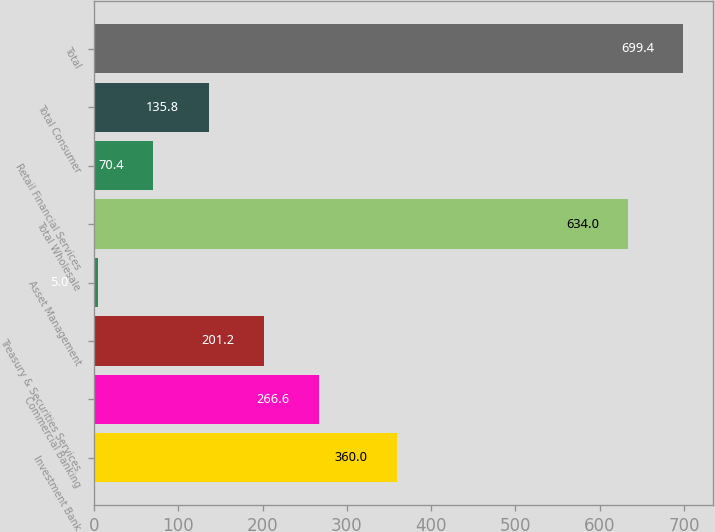Convert chart. <chart><loc_0><loc_0><loc_500><loc_500><bar_chart><fcel>Investment Bank<fcel>Commercial Banking<fcel>Treasury & Securities Services<fcel>Asset Management<fcel>Total Wholesale<fcel>Retail Financial Services<fcel>Total Consumer<fcel>Total<nl><fcel>360<fcel>266.6<fcel>201.2<fcel>5<fcel>634<fcel>70.4<fcel>135.8<fcel>699.4<nl></chart> 